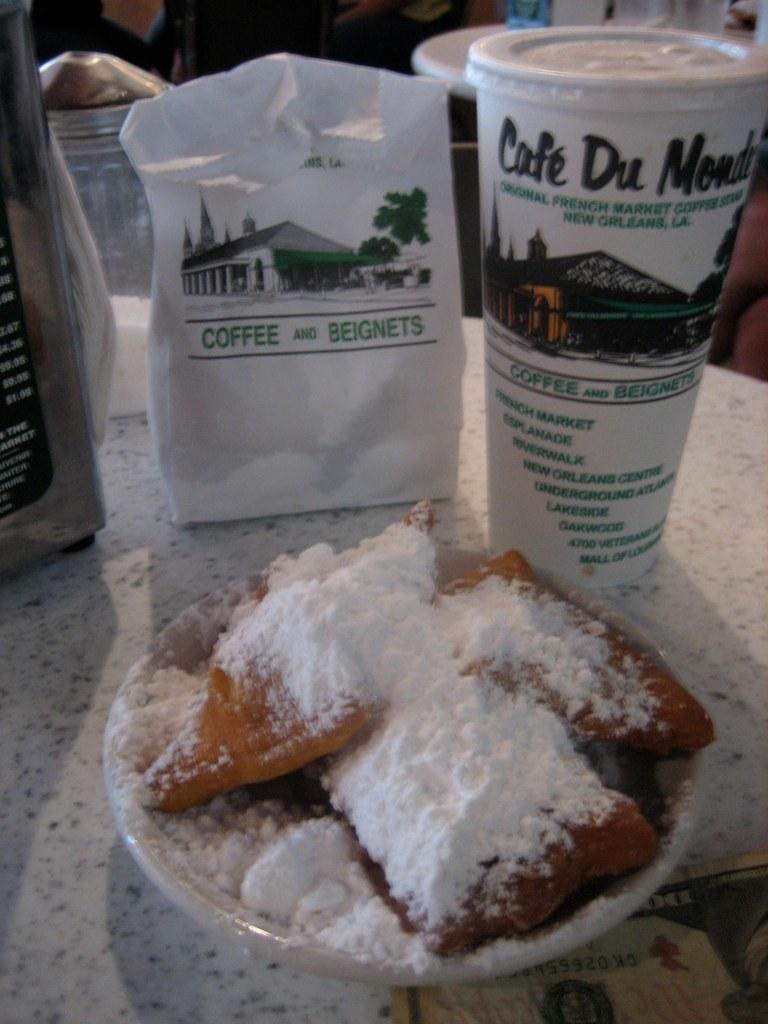How would you summarize this image in a sentence or two? In this picture, we see a white table on which a plate containing eatables, coffee bottle and plastic bag are placed. Behind that, we see people. This picture might be clicked in the hotel. 